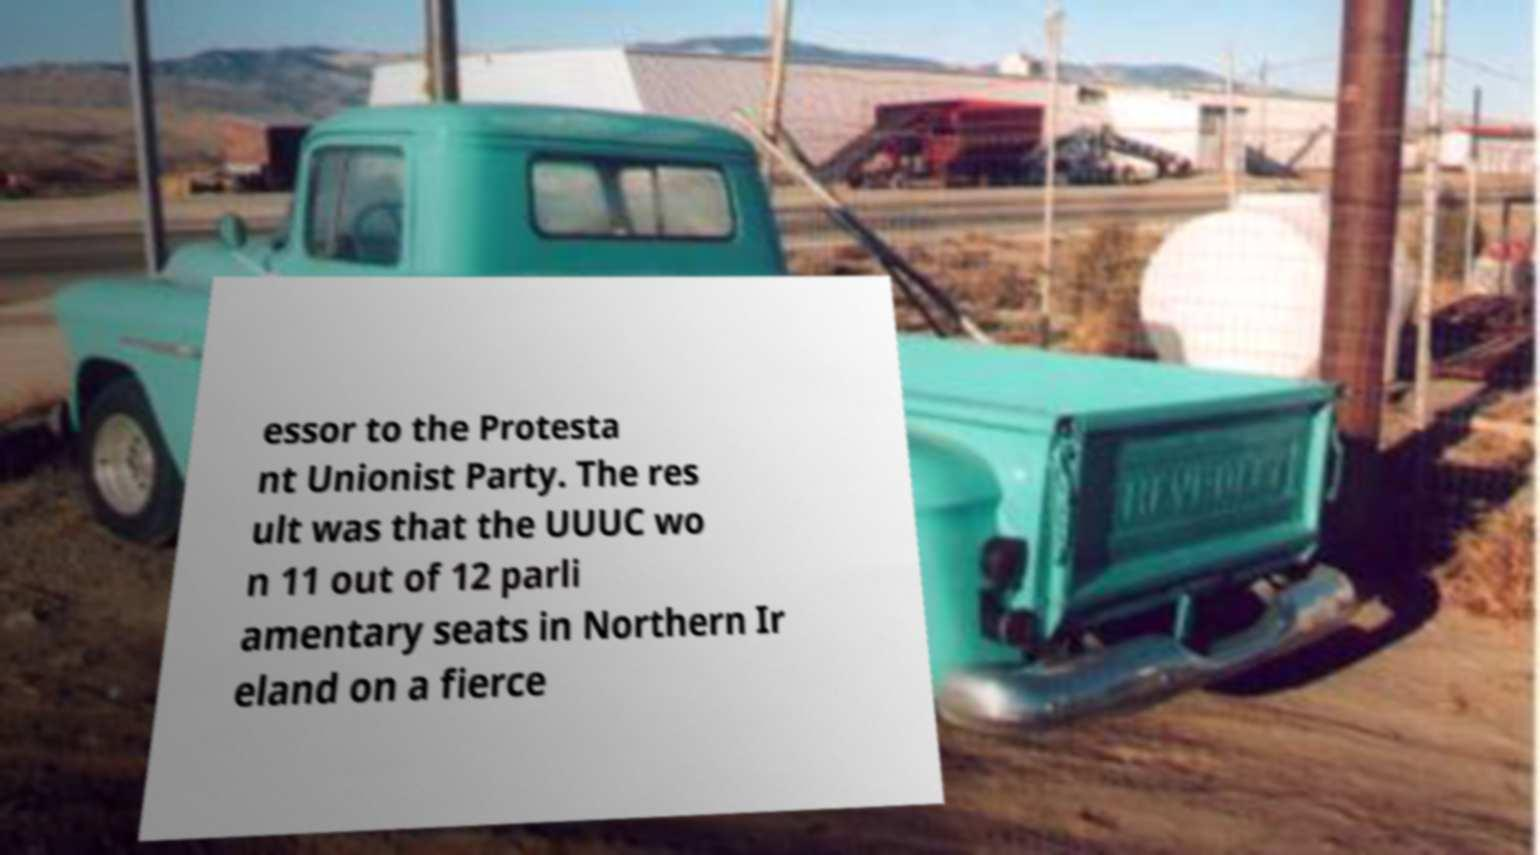I need the written content from this picture converted into text. Can you do that? essor to the Protesta nt Unionist Party. The res ult was that the UUUC wo n 11 out of 12 parli amentary seats in Northern Ir eland on a fierce 